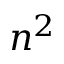Convert formula to latex. <formula><loc_0><loc_0><loc_500><loc_500>n ^ { 2 }</formula> 